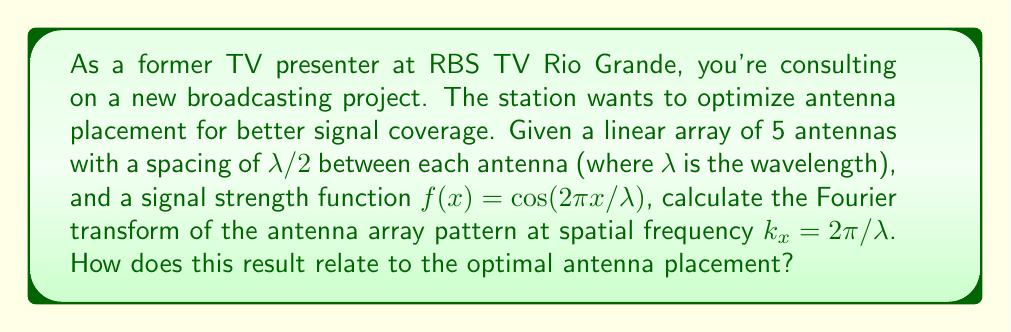Can you answer this question? To solve this problem, we'll follow these steps:

1) First, recall that for a linear array of N antennas, the array factor (AF) is given by:

   $$AF(\theta) = \sum_{n=0}^{N-1} a_n e^{jknd\sin\theta}$$

   where $a_n$ is the complex weight of the nth antenna, k is the wavenumber $(2\pi/\lambda)$, d is the spacing between antennas, and $\theta$ is the angle from broadside.

2) In our case, N = 5, d = $\lambda/2$, and we assume uniform weighting $(a_n = 1)$. The signal strength function $f(x) = \cos(2\pi x/\lambda)$ represents the field pattern of a single antenna.

3) The Fourier transform of the array pattern is effectively sampling this continuous function at the antenna locations. For 5 antennas spaced at $\lambda/2$, these locations are at x = 0, $\lambda/2$, $\lambda$, $3\lambda/2$, and $2\lambda$.

4) Evaluating $f(x)$ at these points:
   
   $f(0) = 1$
   $f(\lambda/2) = 0$
   $f(\lambda) = -1$
   $f(3\lambda/2) = 0$
   $f(2\lambda) = 1$

5) The Fourier transform at $k_x = 2\pi/\lambda$ is then:

   $$F(2\pi/\lambda) = \sum_{n=0}^{4} f(n\lambda/2) e^{-j2\pi n/2}$$

6) Substituting the values:

   $$F(2\pi/\lambda) = 1 + 0 + (-1)e^{-j\pi} + 0 + 1e^{-j2\pi}$$

7) Simplify:

   $$F(2\pi/\lambda) = 1 + 1 + 1 = 3$$

8) This result indicates that the antenna array has a strong response at this spatial frequency, which corresponds to the spacing between the antennas.

9) For optimal antenna placement, this strong response at $k_x = 2\pi/\lambda$ suggests that the $\lambda/2$ spacing is effective for this particular signal. It allows constructive interference in the desired direction while minimizing grating lobes.
Answer: The Fourier transform of the antenna array pattern at spatial frequency $k_x = 2\pi/\lambda$ is 3. This result indicates that the $\lambda/2$ spacing between antennas is optimal for this signal, as it provides strong directional gain and minimizes unwanted grating lobes. 